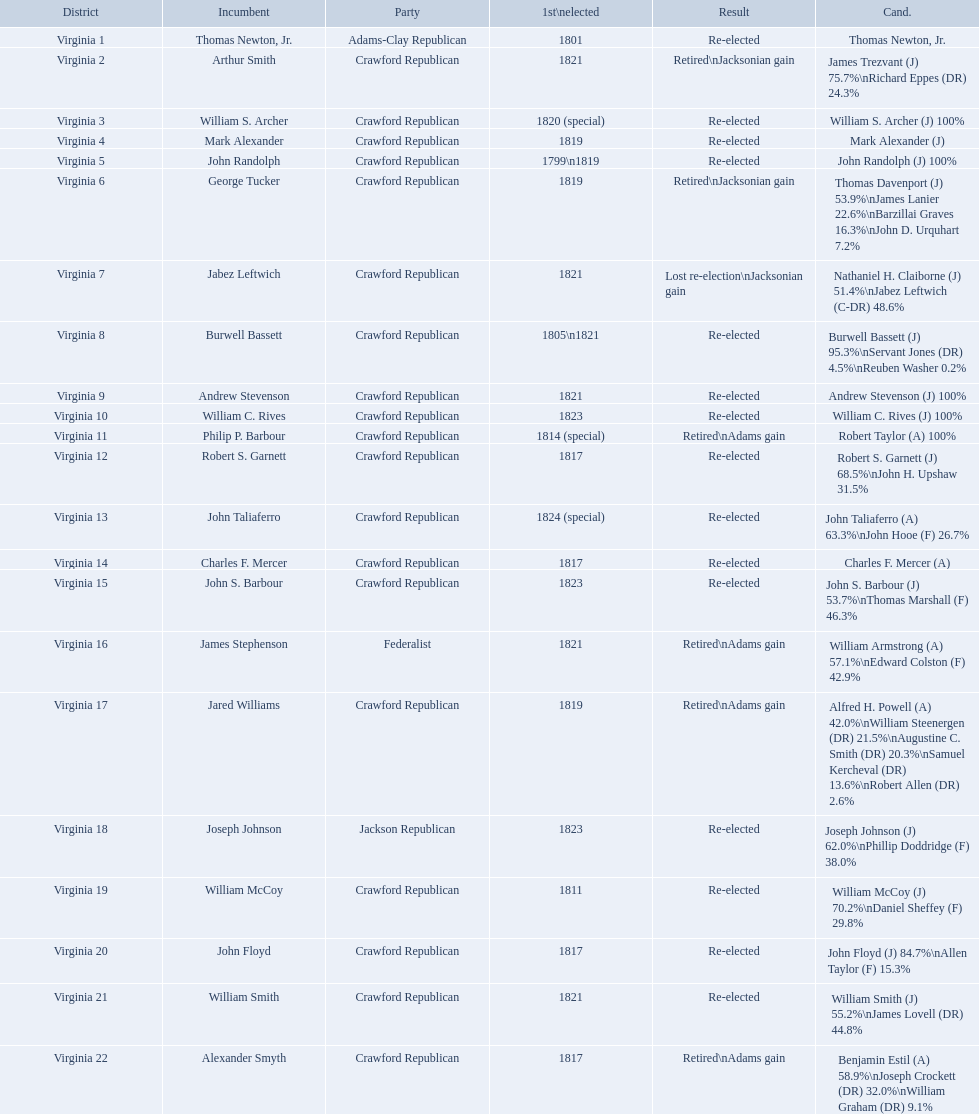Which incumbents belonged to the crawford republican party? Arthur Smith, William S. Archer, Mark Alexander, John Randolph, George Tucker, Jabez Leftwich, Burwell Bassett, Andrew Stevenson, William C. Rives, Philip P. Barbour, Robert S. Garnett, John Taliaferro, Charles F. Mercer, John S. Barbour, Jared Williams, William McCoy, John Floyd, William Smith, Alexander Smyth. Which of these incumbents were first elected in 1821? Arthur Smith, Jabez Leftwich, Andrew Stevenson, William Smith. Which of these incumbents have a last name of smith? Arthur Smith, William Smith. Which of these two were not re-elected? Arthur Smith. What party is a crawford republican? Crawford Republican, Crawford Republican, Crawford Republican, Crawford Republican, Crawford Republican, Crawford Republican, Crawford Republican, Crawford Republican, Crawford Republican, Crawford Republican, Crawford Republican, Crawford Republican, Crawford Republican, Crawford Republican, Crawford Republican, Crawford Republican, Crawford Republican, Crawford Republican, Crawford Republican. What candidates have over 76%? James Trezvant (J) 75.7%\nRichard Eppes (DR) 24.3%, William S. Archer (J) 100%, John Randolph (J) 100%, Burwell Bassett (J) 95.3%\nServant Jones (DR) 4.5%\nReuben Washer 0.2%, Andrew Stevenson (J) 100%, William C. Rives (J) 100%, Robert Taylor (A) 100%, John Floyd (J) 84.7%\nAllen Taylor (F) 15.3%. Which result was retired jacksonian gain? Retired\nJacksonian gain. Who was the incumbent? Arthur Smith. 